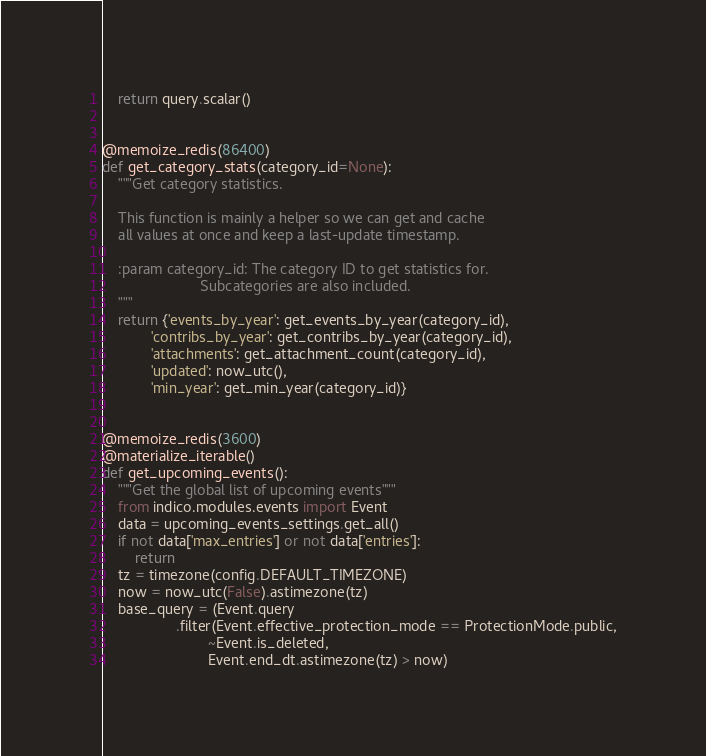<code> <loc_0><loc_0><loc_500><loc_500><_Python_>    return query.scalar()


@memoize_redis(86400)
def get_category_stats(category_id=None):
    """Get category statistics.

    This function is mainly a helper so we can get and cache
    all values at once and keep a last-update timestamp.

    :param category_id: The category ID to get statistics for.
                        Subcategories are also included.
    """
    return {'events_by_year': get_events_by_year(category_id),
            'contribs_by_year': get_contribs_by_year(category_id),
            'attachments': get_attachment_count(category_id),
            'updated': now_utc(),
            'min_year': get_min_year(category_id)}


@memoize_redis(3600)
@materialize_iterable()
def get_upcoming_events():
    """Get the global list of upcoming events"""
    from indico.modules.events import Event
    data = upcoming_events_settings.get_all()
    if not data['max_entries'] or not data['entries']:
        return
    tz = timezone(config.DEFAULT_TIMEZONE)
    now = now_utc(False).astimezone(tz)
    base_query = (Event.query
                  .filter(Event.effective_protection_mode == ProtectionMode.public,
                          ~Event.is_deleted,
                          Event.end_dt.astimezone(tz) > now)</code> 